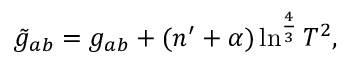<formula> <loc_0><loc_0><loc_500><loc_500>\tilde { g } _ { a b } = g _ { a b } + ( n ^ { \prime } + \alpha ) \ln ^ { \frac { 4 } { 3 } } T ^ { 2 } ,</formula> 